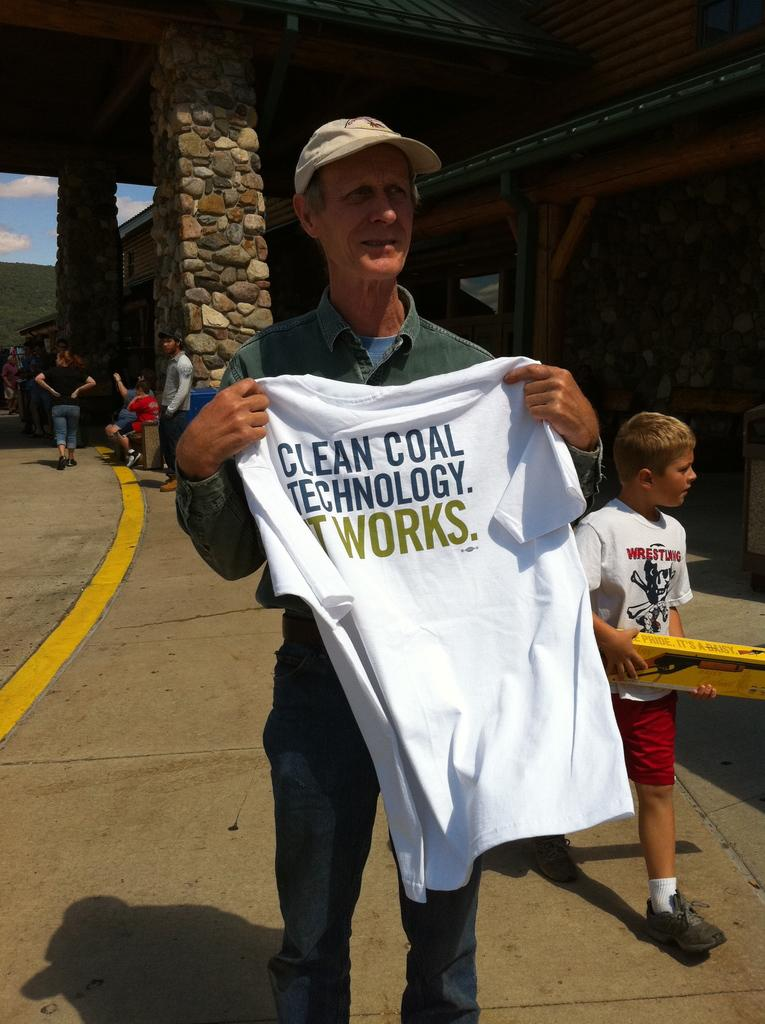<image>
Offer a succinct explanation of the picture presented. the words clean coal that are on a shirt 